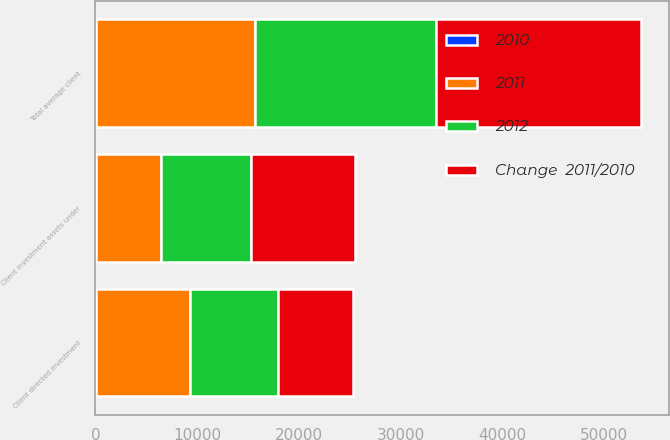Convert chart to OTSL. <chart><loc_0><loc_0><loc_500><loc_500><stacked_bar_chart><ecel><fcel>Client directed investment<fcel>Client investment assets under<fcel>Total average client<nl><fcel>Change  2011/2010<fcel>7335<fcel>10282<fcel>20213<nl><fcel>2012<fcel>8683<fcel>8803<fcel>17736<nl><fcel>2010<fcel>15.5<fcel>16.8<fcel>14<nl><fcel>2011<fcel>9279<fcel>6432<fcel>15711<nl></chart> 